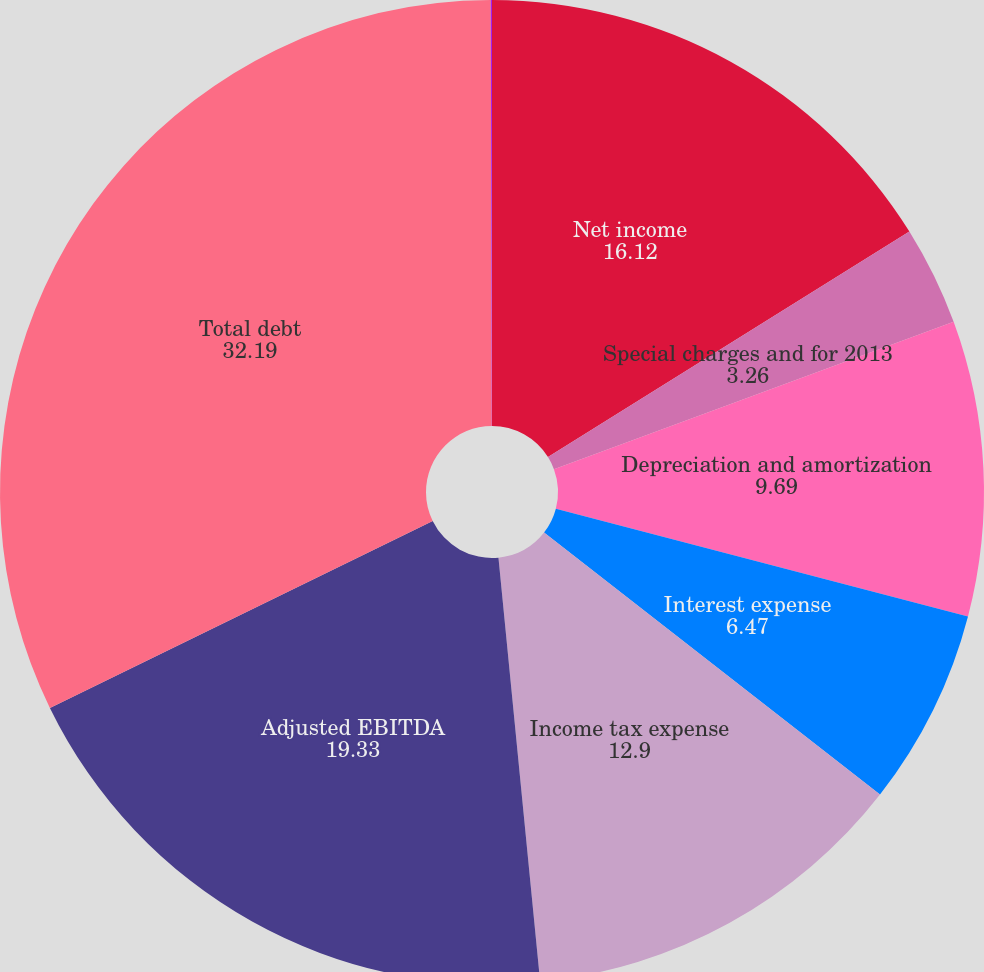<chart> <loc_0><loc_0><loc_500><loc_500><pie_chart><fcel>Net income<fcel>Special charges and for 2013<fcel>Depreciation and amortization<fcel>Interest expense<fcel>Income tax expense<fcel>Adjusted EBITDA<fcel>Total debt<fcel>Total debt/adjusted EBITDA<nl><fcel>16.12%<fcel>3.26%<fcel>9.69%<fcel>6.47%<fcel>12.9%<fcel>19.33%<fcel>32.19%<fcel>0.04%<nl></chart> 